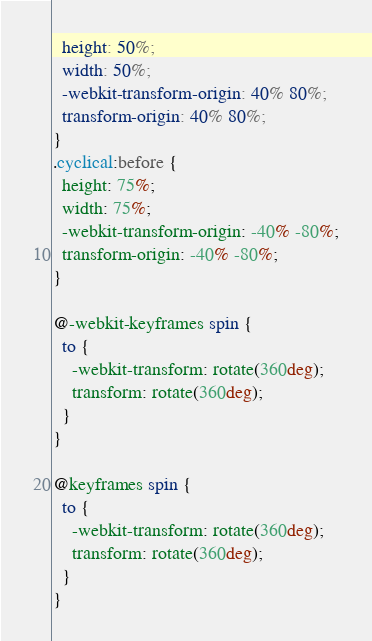<code> <loc_0><loc_0><loc_500><loc_500><_CSS_>  height: 50%;
  width: 50%;
  -webkit-transform-origin: 40% 80%;
  transform-origin: 40% 80%;
}
.cyclical:before {
  height: 75%;
  width: 75%;
  -webkit-transform-origin: -40% -80%;
  transform-origin: -40% -80%;
}

@-webkit-keyframes spin {
  to {
    -webkit-transform: rotate(360deg);
    transform: rotate(360deg);
  }
}

@keyframes spin {
  to {
    -webkit-transform: rotate(360deg);
    transform: rotate(360deg);
  }
}
</code> 